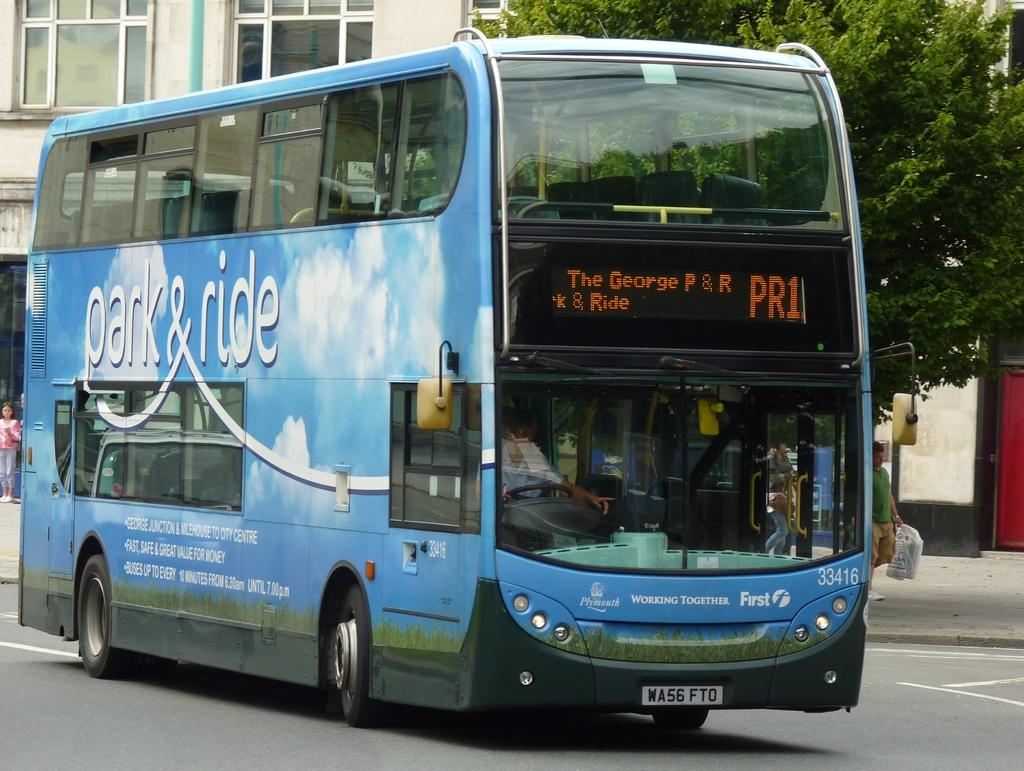What is the main subject in the foreground of the image? There is a bus in the foreground of the image. What else can be seen in the foreground of the image? There is a group of people on the road in the foreground of the image. What can be seen in the background of the image? There are buildings and a tree in the background of the image. Where was the image taken? The image was taken on the road. What type of bell can be heard ringing in the image? There is no bell present in the image, and therefore no sound can be heard. 